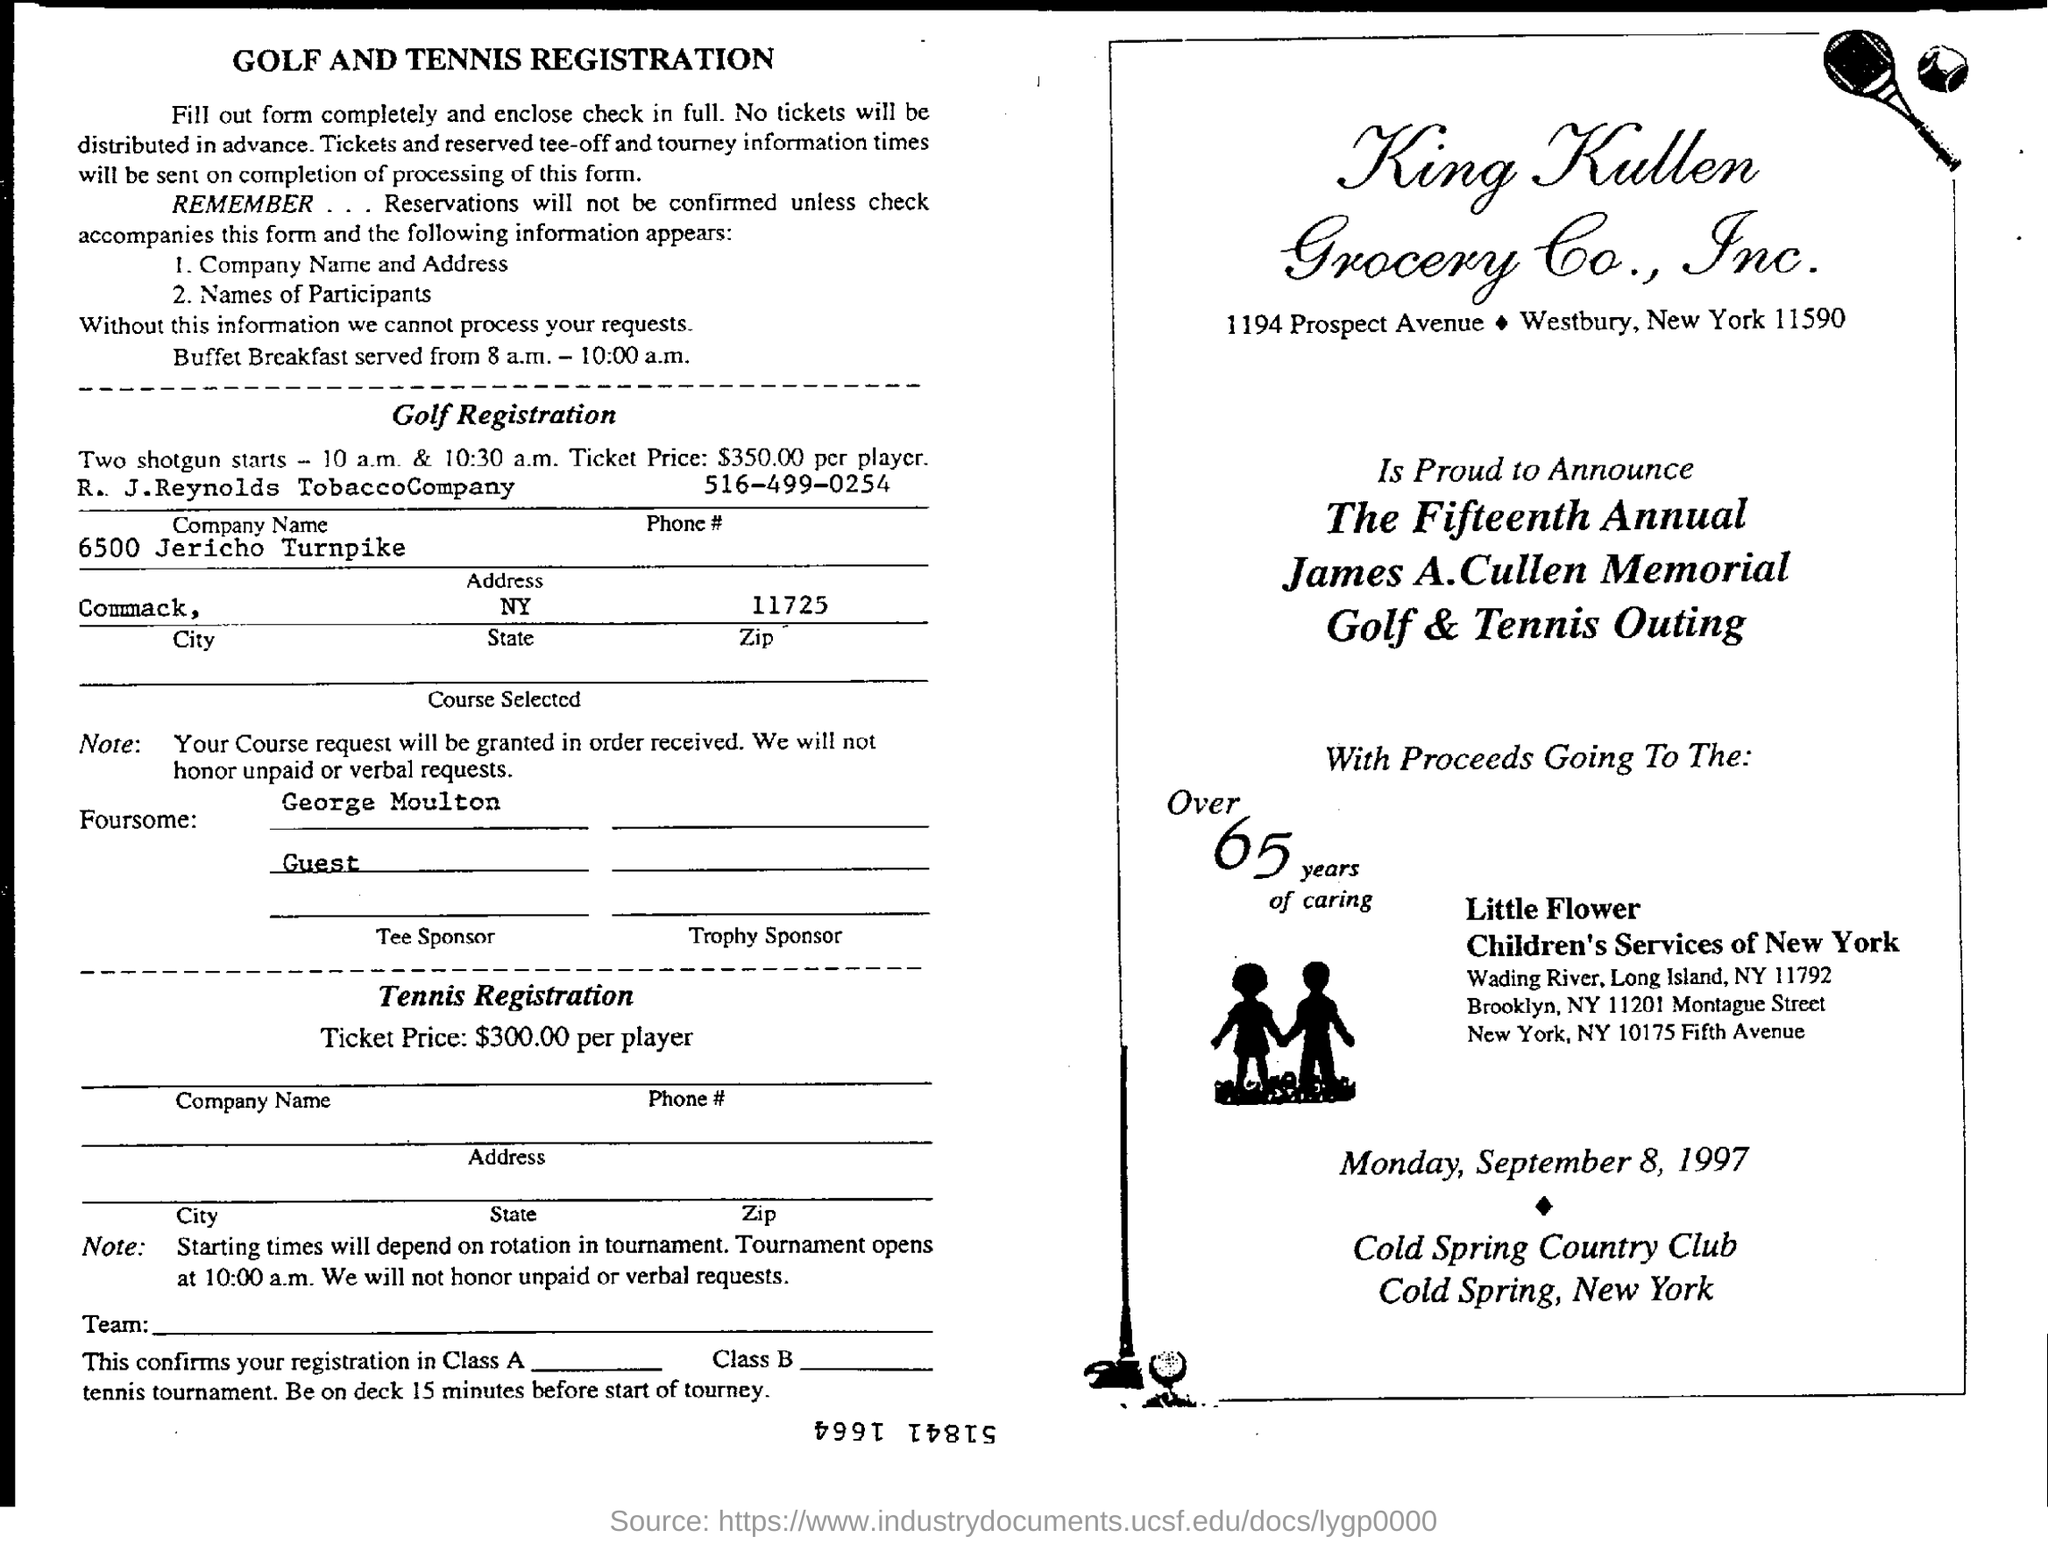Draw attention to some important aspects in this diagram. The Golf & Tennis Outing will be held on Monday, September 8, 1997. The golf registration ticket price is $350.00 per player. The ticket price for tennis registration is $300.00. The timing of the Buffet Breakfast is from 8:00 a.m. to 10:00 a.m. 